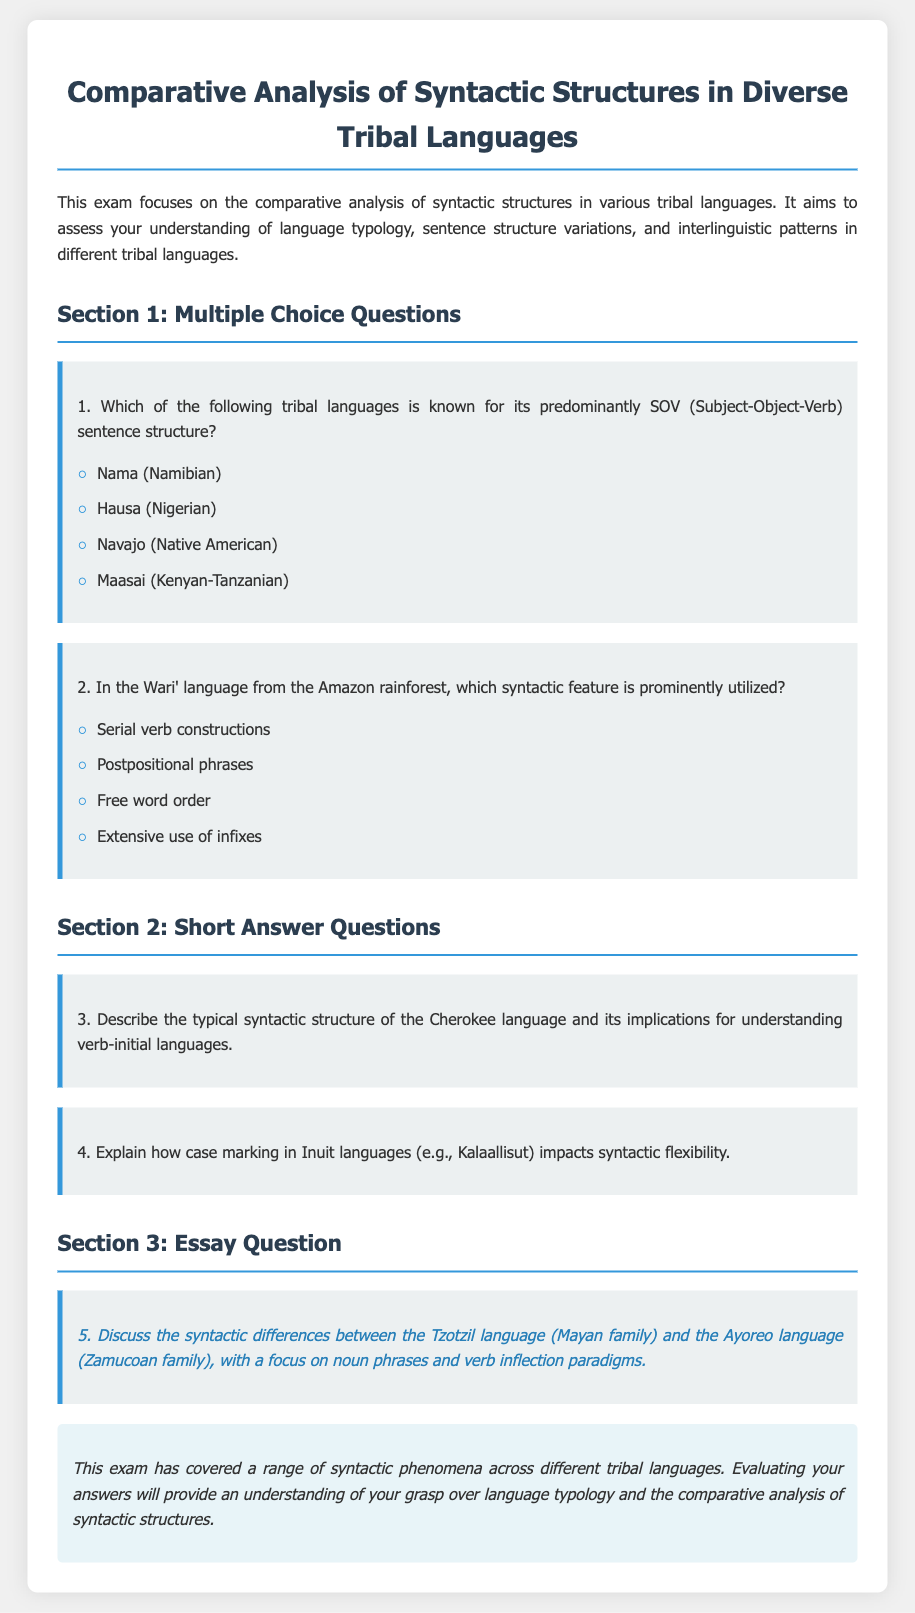What is the title of the exam? The title of the exam is provided at the top of the document.
Answer: Comparative Analysis of Syntactic Structures in Diverse Tribal Languages How many sections are there in the exam? The document outlines the structure of the exam and mentions the number of sections.
Answer: Three What is the first language listed in Section 1? The languages listed in the multiple-choice questions are identified, and the first one is indicated.
Answer: Nama (Namibian) What syntactic feature is prominently utilized in the Wari' language? The question about Wari' language outlines the specific syntactic feature being examined.
Answer: Serial verb constructions What type of question is number 5? The document specifies the format and type of each question, identifying the fifth as an essay question.
Answer: Essay Question What is the focus of question 4? The question indicates what aspect of Inuit languages is being explored regarding syntactic flexibility.
Answer: Case marking In which section is the question about Cherokee language found? The sections in the document categorize types of questions, indicating where the Cherokee question appears.
Answer: Section 2 What color is primarily used for the title heading? The styling of the document indicates the color used in the title.
Answer: #2c3e50 